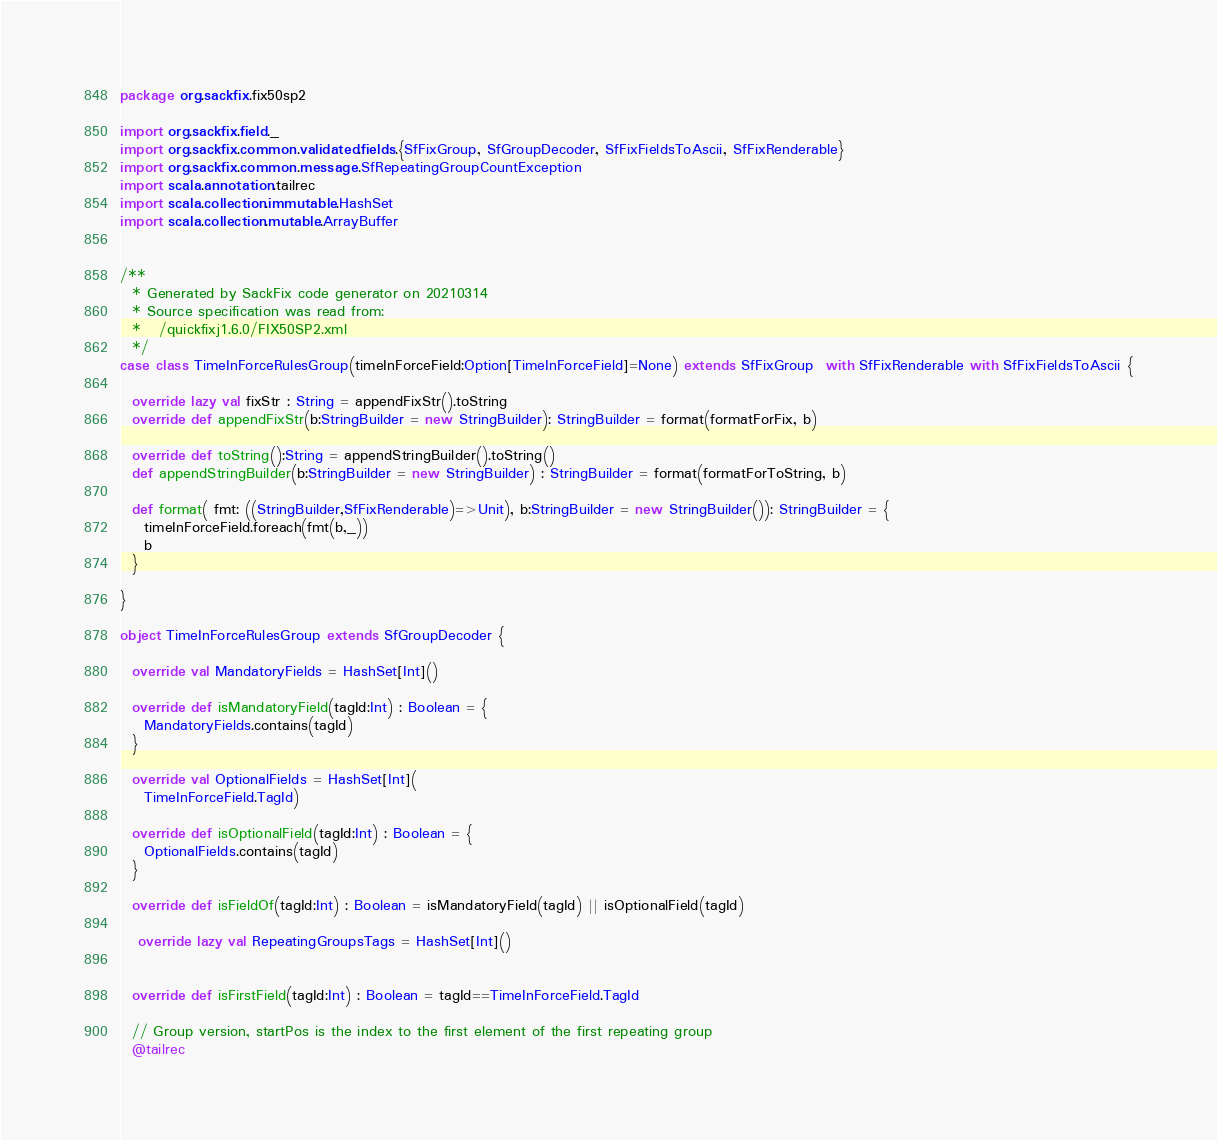Convert code to text. <code><loc_0><loc_0><loc_500><loc_500><_Scala_>package org.sackfix.fix50sp2

import org.sackfix.field._
import org.sackfix.common.validated.fields.{SfFixGroup, SfGroupDecoder, SfFixFieldsToAscii, SfFixRenderable}
import org.sackfix.common.message.SfRepeatingGroupCountException
import scala.annotation.tailrec
import scala.collection.immutable.HashSet
import scala.collection.mutable.ArrayBuffer


/**
  * Generated by SackFix code generator on 20210314
  * Source specification was read from:
  *   /quickfixj1.6.0/FIX50SP2.xml
  */
case class TimeInForceRulesGroup(timeInForceField:Option[TimeInForceField]=None) extends SfFixGroup  with SfFixRenderable with SfFixFieldsToAscii {

  override lazy val fixStr : String = appendFixStr().toString
  override def appendFixStr(b:StringBuilder = new StringBuilder): StringBuilder = format(formatForFix, b)

  override def toString():String = appendStringBuilder().toString()
  def appendStringBuilder(b:StringBuilder = new StringBuilder) : StringBuilder = format(formatForToString, b)

  def format( fmt: ((StringBuilder,SfFixRenderable)=>Unit), b:StringBuilder = new StringBuilder()): StringBuilder = {
    timeInForceField.foreach(fmt(b,_))
    b
  }

}
     
object TimeInForceRulesGroup extends SfGroupDecoder {

  override val MandatoryFields = HashSet[Int]()

  override def isMandatoryField(tagId:Int) : Boolean = {
    MandatoryFields.contains(tagId) 
  }

  override val OptionalFields = HashSet[Int](
    TimeInForceField.TagId)

  override def isOptionalField(tagId:Int) : Boolean = {
    OptionalFields.contains(tagId) 
  }

  override def isFieldOf(tagId:Int) : Boolean = isMandatoryField(tagId) || isOptionalField(tagId) 

   override lazy val RepeatingGroupsTags = HashSet[Int]()
  
      
  override def isFirstField(tagId:Int) : Boolean = tagId==TimeInForceField.TagId 

  // Group version, startPos is the index to the first element of the first repeating group
  @tailrec</code> 